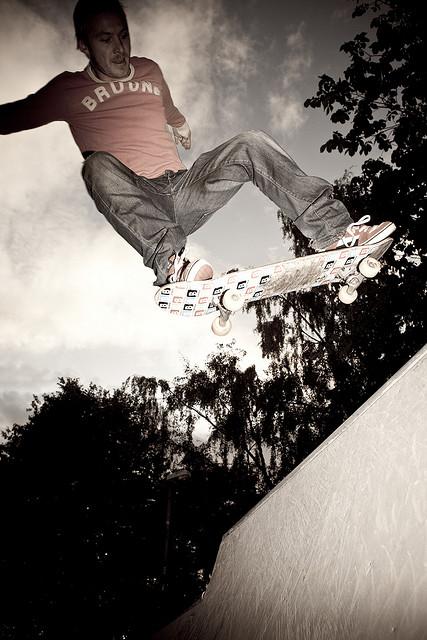How many feet are touching the skateboard?
Be succinct. 2. What word is on the shirt?
Concise answer only. Brunei. What is he doing?
Quick response, please. Skateboarding. 